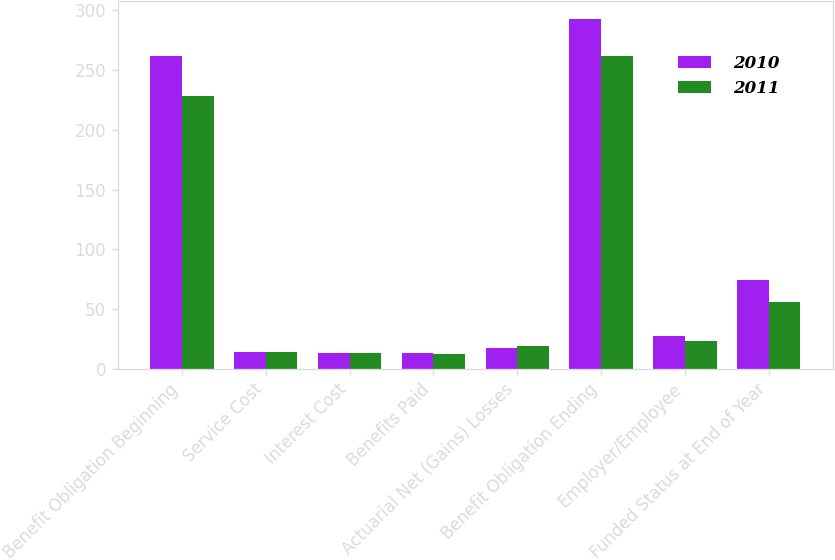<chart> <loc_0><loc_0><loc_500><loc_500><stacked_bar_chart><ecel><fcel>Benefit Obligation Beginning<fcel>Service Cost<fcel>Interest Cost<fcel>Benefits Paid<fcel>Actuarial Net (Gains) Losses<fcel>Benefit Obligation Ending<fcel>Employer/Employee<fcel>Funded Status at End of Year<nl><fcel>2010<fcel>262<fcel>14<fcel>13<fcel>13<fcel>17<fcel>293<fcel>27<fcel>74<nl><fcel>2011<fcel>228<fcel>14<fcel>13<fcel>12<fcel>19<fcel>262<fcel>23<fcel>56<nl></chart> 